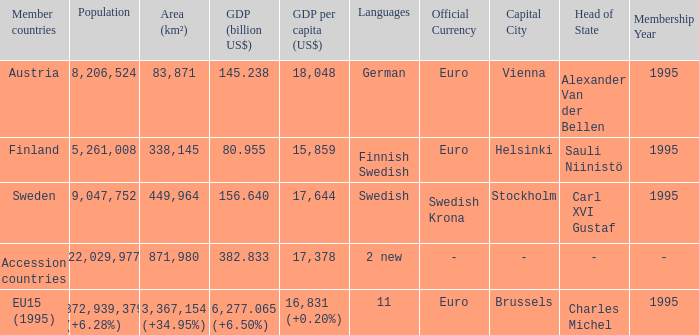Name the member countries for finnish swedish Finland. 